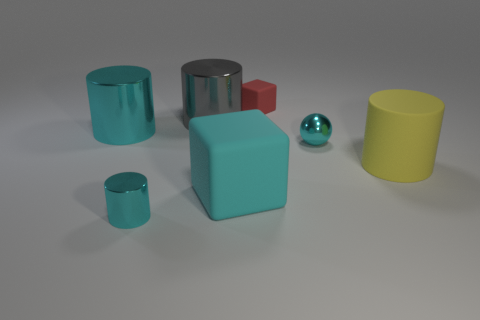Are there fewer cyan blocks than yellow shiny cylinders?
Provide a succinct answer. No. What is the cyan object that is both right of the tiny cyan cylinder and on the left side of the tiny cube made of?
Your response must be concise. Rubber. How big is the metal thing behind the large cylinder that is left of the small cyan object that is on the left side of the big cyan rubber cube?
Your answer should be compact. Large. There is a small red matte object; is its shape the same as the small cyan shiny object left of the cyan ball?
Provide a succinct answer. No. How many objects are in front of the tiny metal ball and to the left of the big yellow thing?
Ensure brevity in your answer.  2. What number of gray things are either large metal objects or shiny cylinders?
Your answer should be compact. 1. Is the color of the tiny object to the left of the large block the same as the metallic object to the left of the tiny cyan cylinder?
Your response must be concise. Yes. There is a rubber block that is in front of the large metal cylinder that is on the left side of the large gray cylinder that is to the left of the cyan metallic ball; what is its color?
Make the answer very short. Cyan. Are there any cylinders to the left of the tiny cyan object that is in front of the cyan cube?
Offer a very short reply. Yes. There is a small metallic thing on the left side of the metal sphere; is it the same shape as the large gray thing?
Provide a short and direct response. Yes. 